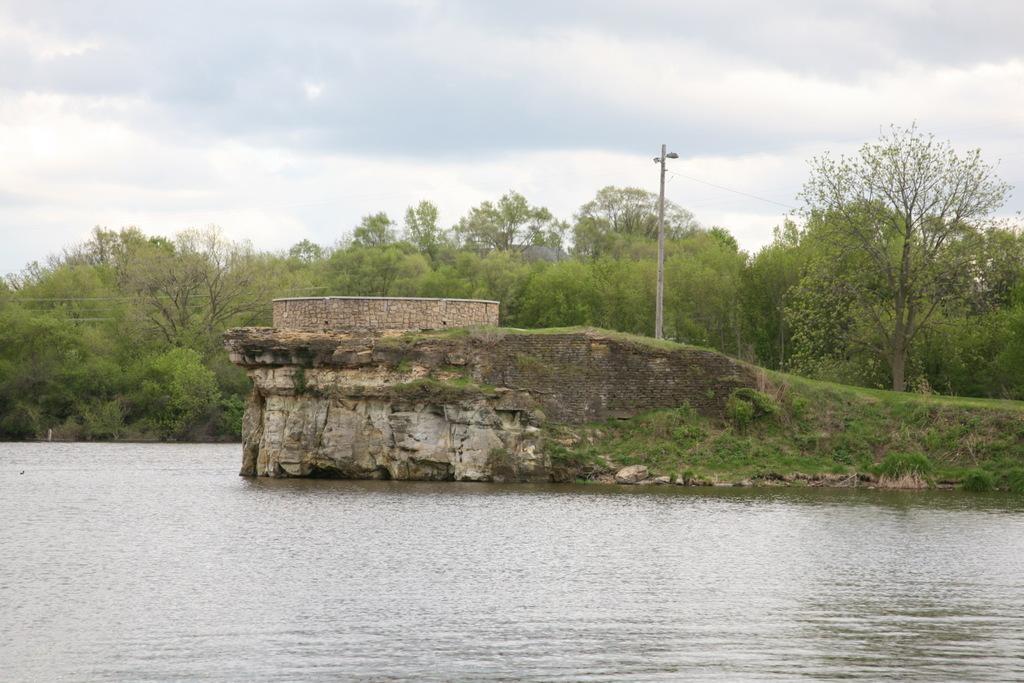What is at the bottom of the image? There is water at the bottom of the image. What can be seen in the background of the image? There are trees, a pole, and grass in the background of the image. What is visible at the top of the image? The sky is visible at the top of the image. What can be observed in the sky? Clouds are present in the sky. How many pipes can be seen in the image? There are no pipes present in the image. What type of kite is being flown in the image? There is no kite present in the image. 